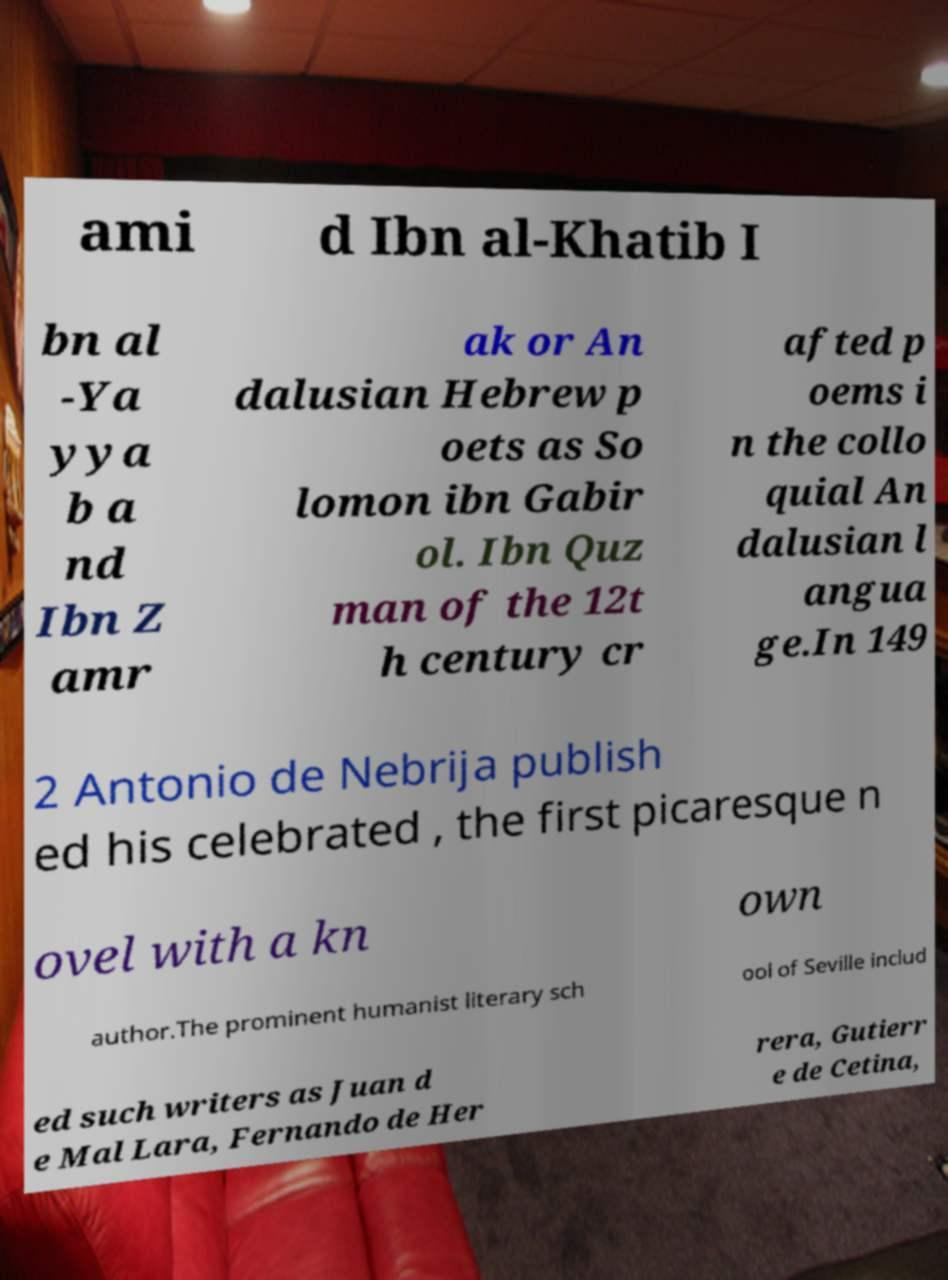There's text embedded in this image that I need extracted. Can you transcribe it verbatim? ami d Ibn al-Khatib I bn al -Ya yya b a nd Ibn Z amr ak or An dalusian Hebrew p oets as So lomon ibn Gabir ol. Ibn Quz man of the 12t h century cr afted p oems i n the collo quial An dalusian l angua ge.In 149 2 Antonio de Nebrija publish ed his celebrated , the first picaresque n ovel with a kn own author.The prominent humanist literary sch ool of Seville includ ed such writers as Juan d e Mal Lara, Fernando de Her rera, Gutierr e de Cetina, 